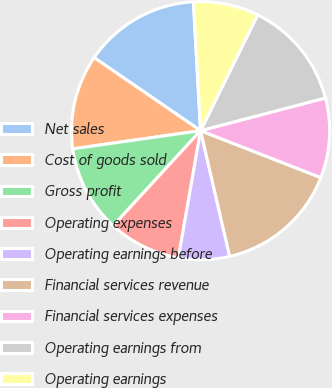Convert chart. <chart><loc_0><loc_0><loc_500><loc_500><pie_chart><fcel>Net sales<fcel>Cost of goods sold<fcel>Gross profit<fcel>Operating expenses<fcel>Operating earnings before<fcel>Financial services revenue<fcel>Financial services expenses<fcel>Operating earnings from<fcel>Operating earnings<nl><fcel>14.54%<fcel>11.82%<fcel>10.91%<fcel>9.09%<fcel>6.37%<fcel>15.45%<fcel>10.0%<fcel>13.63%<fcel>8.18%<nl></chart> 